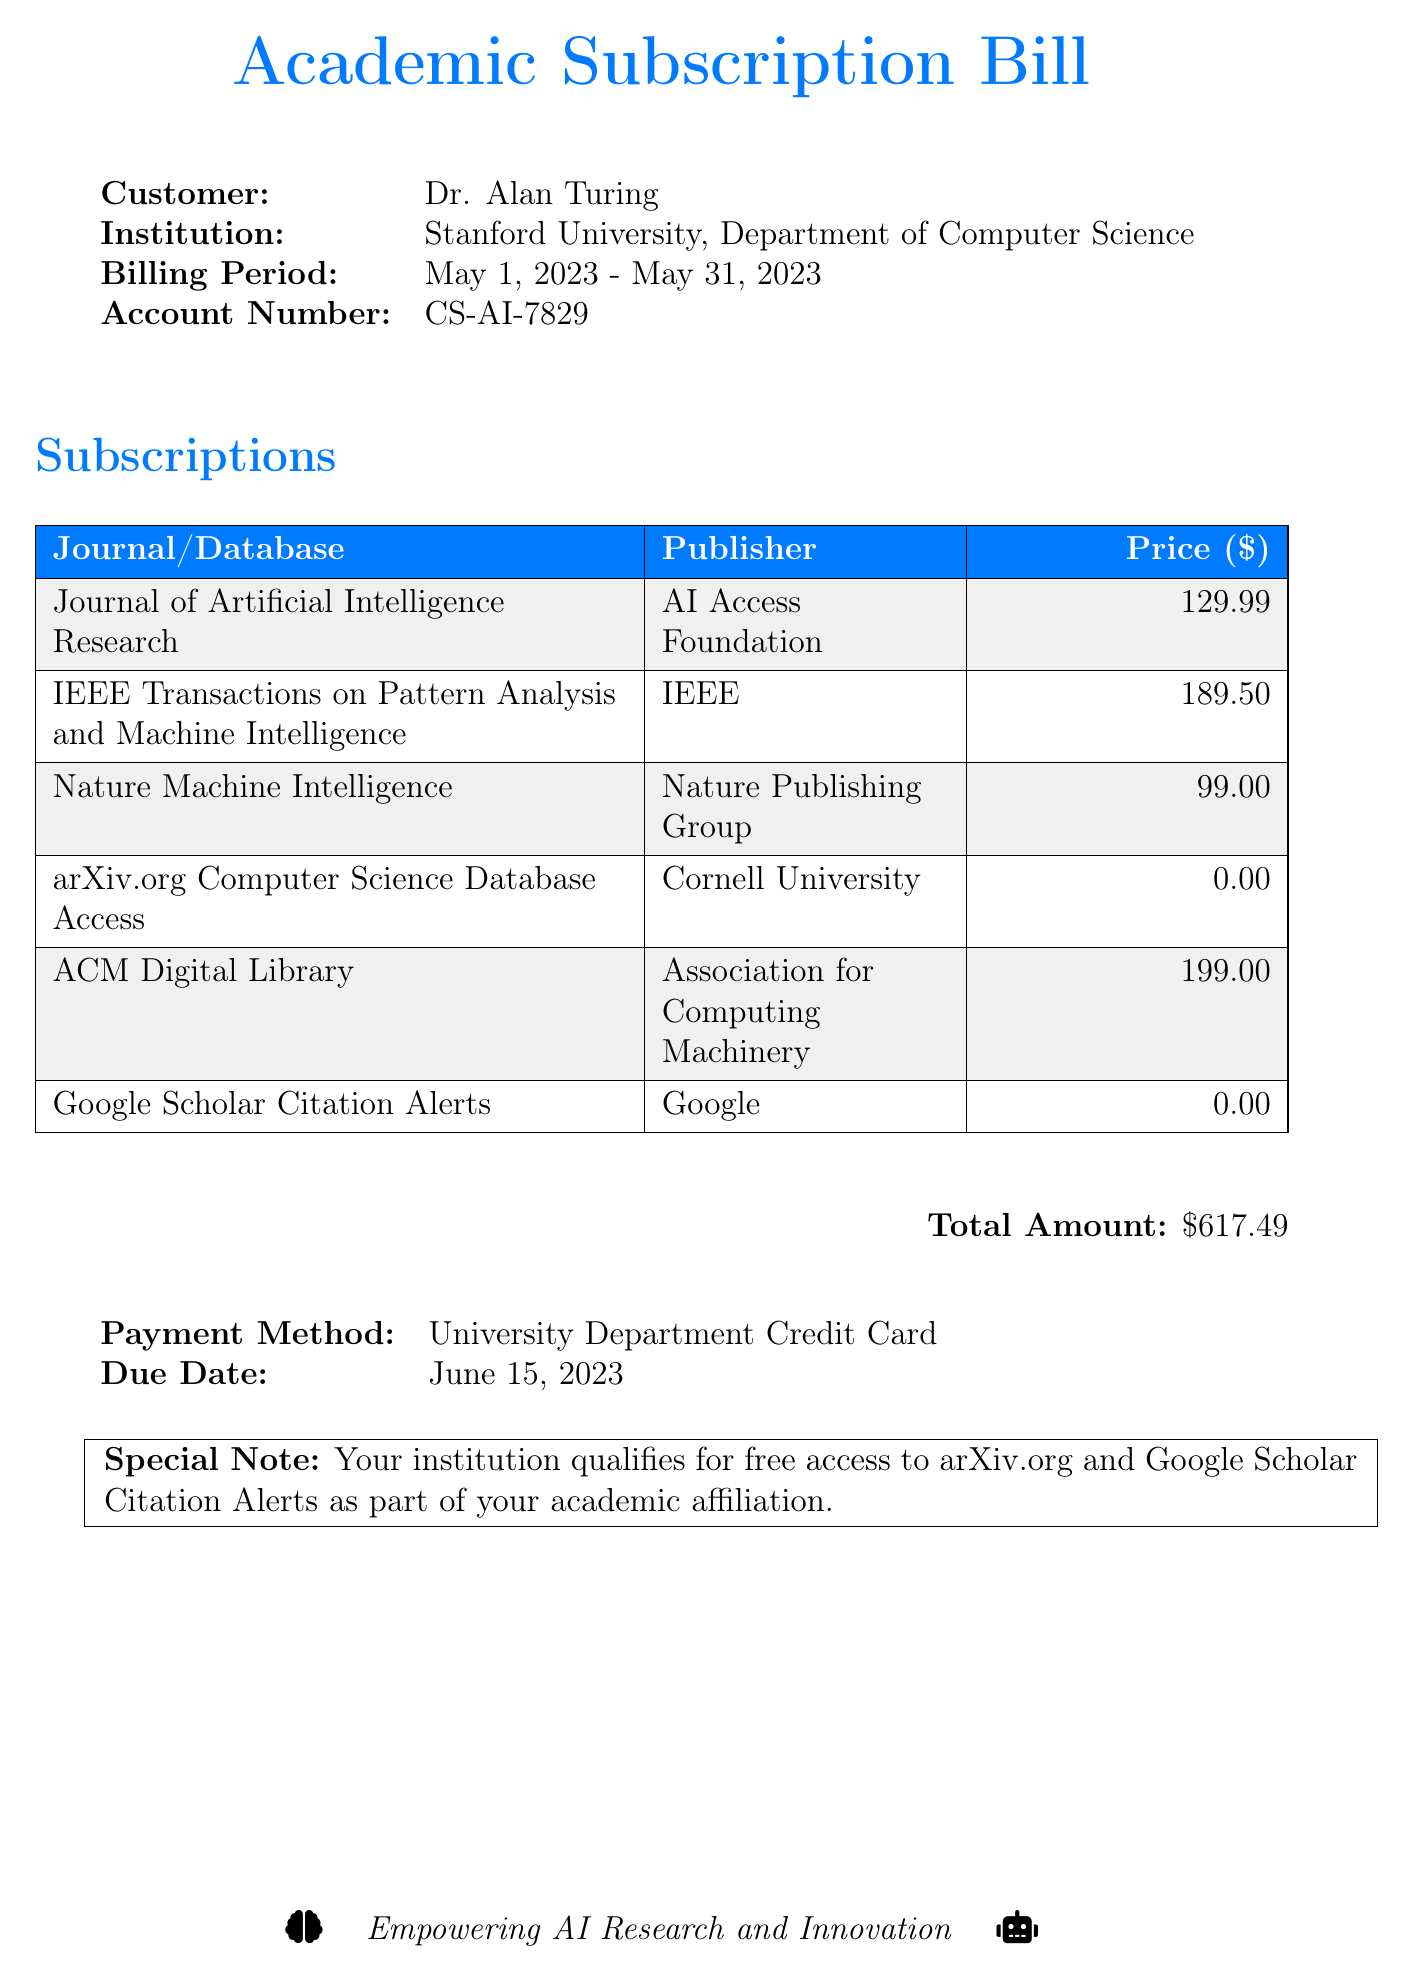What is the customer's name? The document states that the customer's name is Dr. Alan Turing.
Answer: Dr. Alan Turing What is the billing period? The billing period mentioned in the document is from May 1, 2023, to May 31, 2023.
Answer: May 1, 2023 - May 31, 2023 What is the total amount due? The total amount due, as listed in the document, is the sum of subscription prices.
Answer: $617.49 Which journal is published by the AI Access Foundation? The document lists the "Journal of Artificial Intelligence Research" as the journal published by AI Access Foundation.
Answer: Journal of Artificial Intelligence Research What is the due date for the payment? According to the document, the payment is due on June 15, 2023.
Answer: June 15, 2023 Which payment method is mentioned? The payment method specified in the document is a University Department Credit Card.
Answer: University Department Credit Card How many journals have a price of $0.00? The document lists two subscriptions that have a price of $0.00.
Answer: 2 What special note is provided in the document? The document provides a special note indicating free access to certain resources.
Answer: Your institution qualifies for free access to arXiv.org and Google Scholar Citation Alerts 